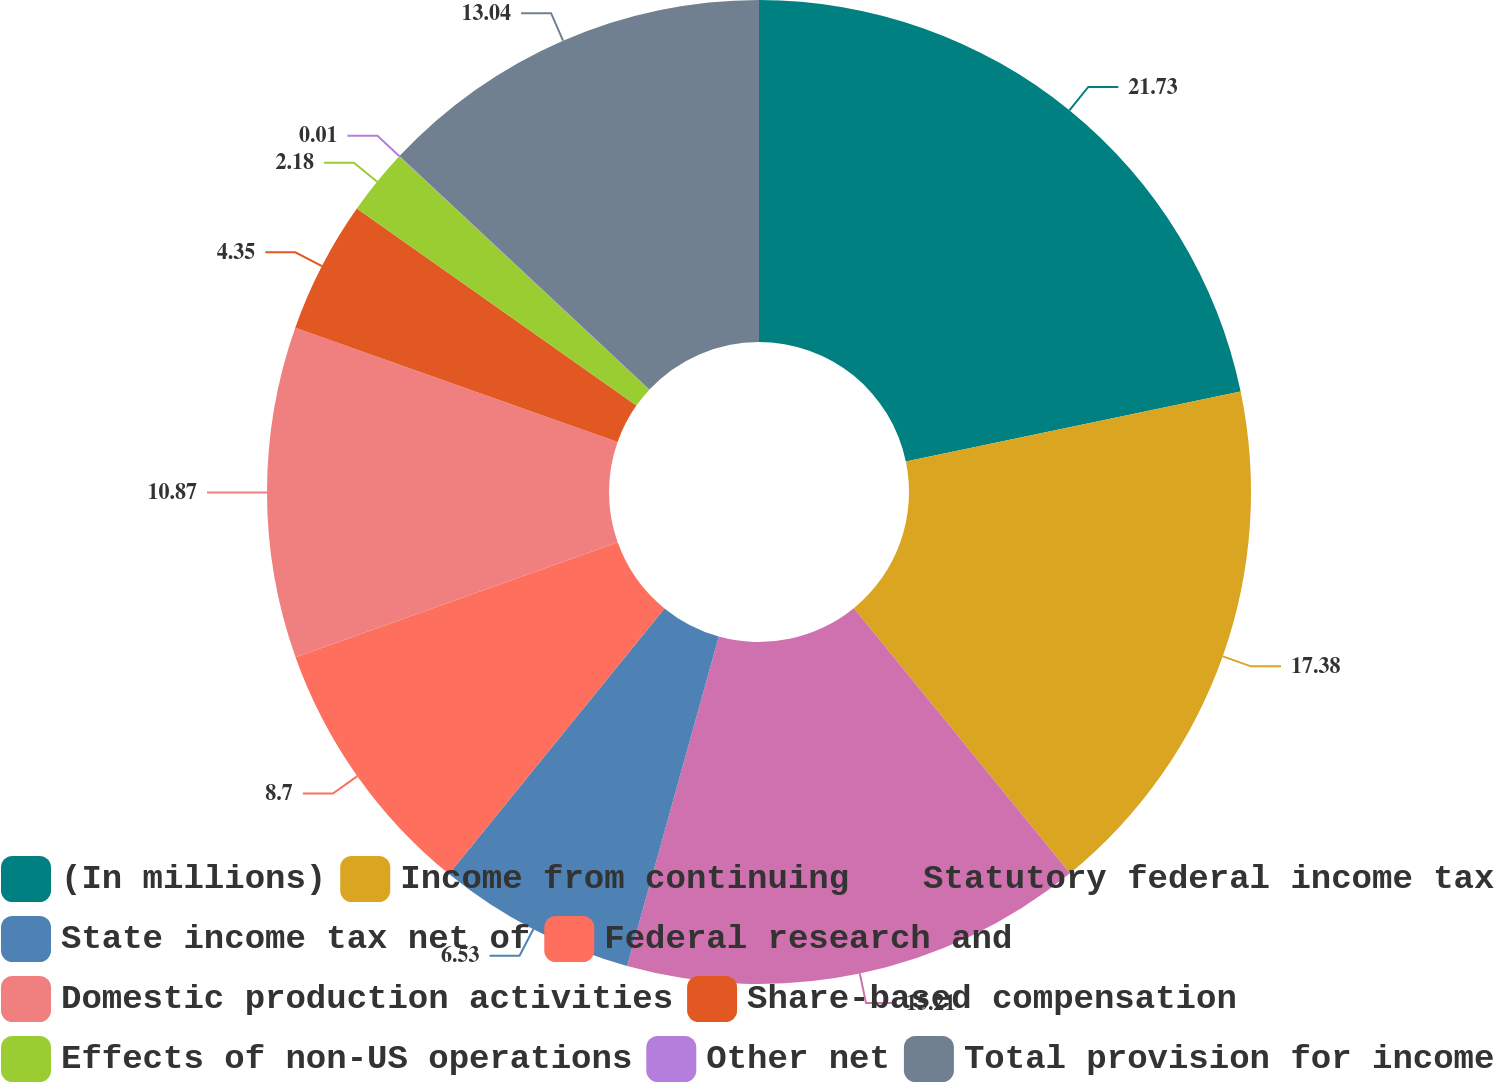Convert chart to OTSL. <chart><loc_0><loc_0><loc_500><loc_500><pie_chart><fcel>(In millions)<fcel>Income from continuing<fcel>Statutory federal income tax<fcel>State income tax net of<fcel>Federal research and<fcel>Domestic production activities<fcel>Share-based compensation<fcel>Effects of non-US operations<fcel>Other net<fcel>Total provision for income<nl><fcel>21.73%<fcel>17.38%<fcel>15.21%<fcel>6.53%<fcel>8.7%<fcel>10.87%<fcel>4.35%<fcel>2.18%<fcel>0.01%<fcel>13.04%<nl></chart> 